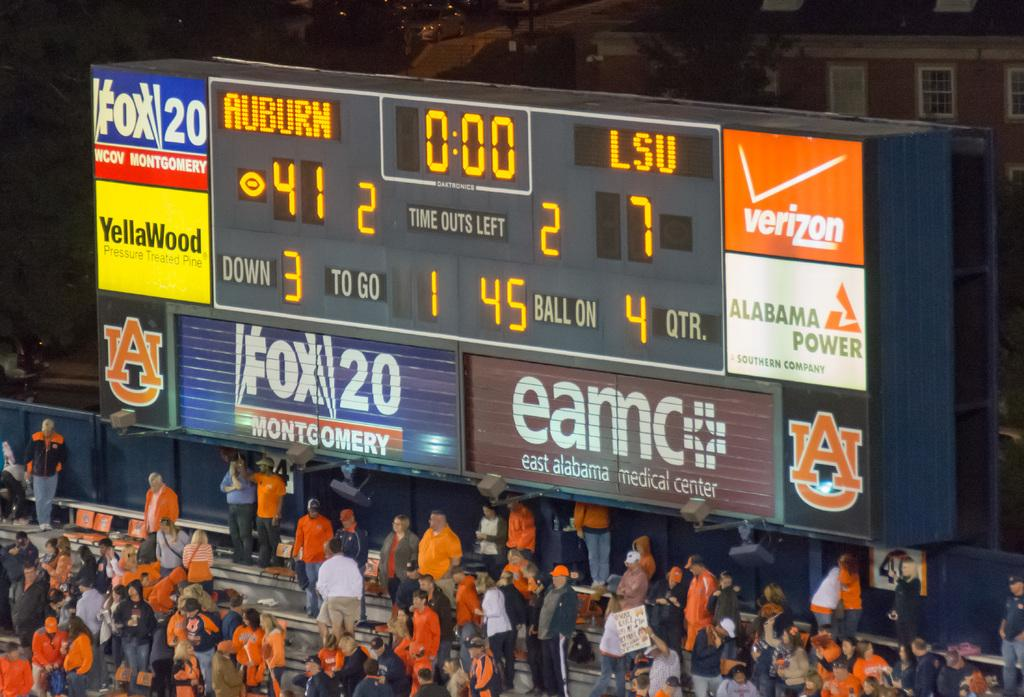<image>
Describe the image concisely. The scoreboard above the stadium at this Auburn football game. 